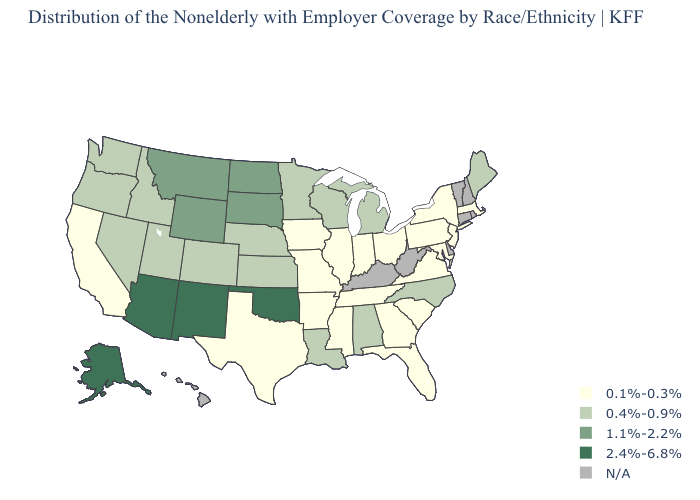What is the value of Illinois?
Give a very brief answer. 0.1%-0.3%. Name the states that have a value in the range 2.4%-6.8%?
Keep it brief. Alaska, Arizona, New Mexico, Oklahoma. Is the legend a continuous bar?
Give a very brief answer. No. What is the lowest value in states that border Michigan?
Give a very brief answer. 0.1%-0.3%. Which states hav the highest value in the MidWest?
Quick response, please. North Dakota, South Dakota. Does Alaska have the highest value in the USA?
Concise answer only. Yes. Name the states that have a value in the range 1.1%-2.2%?
Keep it brief. Montana, North Dakota, South Dakota, Wyoming. Does Massachusetts have the highest value in the Northeast?
Concise answer only. No. What is the lowest value in the Northeast?
Write a very short answer. 0.1%-0.3%. Among the states that border West Virginia , which have the lowest value?
Answer briefly. Maryland, Ohio, Pennsylvania, Virginia. Among the states that border Louisiana , which have the lowest value?
Short answer required. Arkansas, Mississippi, Texas. Is the legend a continuous bar?
Short answer required. No. Name the states that have a value in the range 0.4%-0.9%?
Quick response, please. Alabama, Colorado, Idaho, Kansas, Louisiana, Maine, Michigan, Minnesota, Nebraska, Nevada, North Carolina, Oregon, Utah, Washington, Wisconsin. What is the lowest value in the MidWest?
Answer briefly. 0.1%-0.3%. 